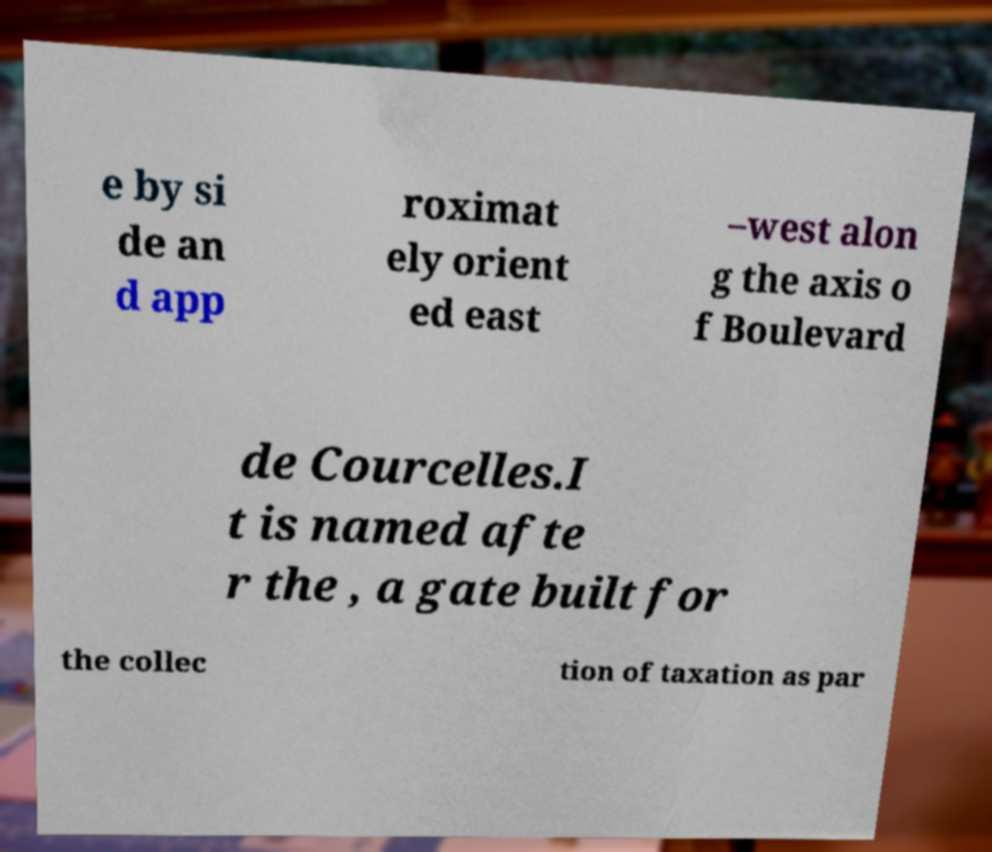Please read and relay the text visible in this image. What does it say? e by si de an d app roximat ely orient ed east –west alon g the axis o f Boulevard de Courcelles.I t is named afte r the , a gate built for the collec tion of taxation as par 